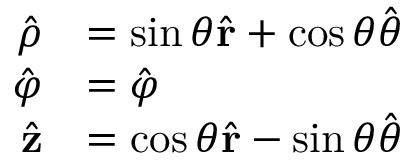<formula> <loc_0><loc_0><loc_500><loc_500>{ \begin{array} { r l } { { \hat { \rho } } } & { = \sin \theta { \hat { r } } + \cos \theta { \hat { \theta } } } \\ { { \hat { \varphi } } } & { = { \hat { \varphi } } } \\ { { \hat { z } } } & { = \cos \theta { \hat { r } } - \sin \theta { \hat { \theta } } } \end{array} }</formula> 